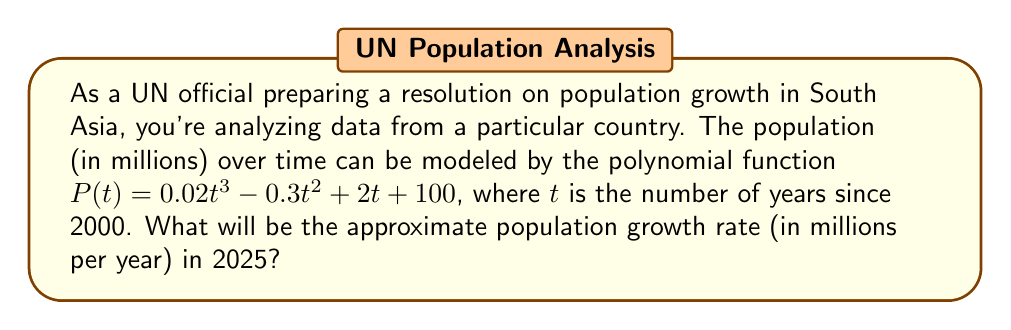Can you solve this math problem? To solve this problem, we need to follow these steps:

1) The population growth rate at any given time is the derivative of the population function. So, we need to find $P'(t)$.

2) To find $P'(t)$, we differentiate $P(t)$ with respect to $t$:
   $$P'(t) = 0.06t^2 - 0.6t + 2$$

3) We want to find the growth rate in 2025, which is 25 years after 2000. So we need to calculate $P'(25)$.

4) Substitute $t = 25$ into $P'(t)$:
   $$P'(25) = 0.06(25)^2 - 0.6(25) + 2$$

5) Simplify:
   $$P'(25) = 0.06(625) - 15 + 2$$
   $$P'(25) = 37.5 - 15 + 2 = 24.5$$

Therefore, the population growth rate in 2025 will be approximately 24.5 million per year.
Answer: 24.5 million per year 